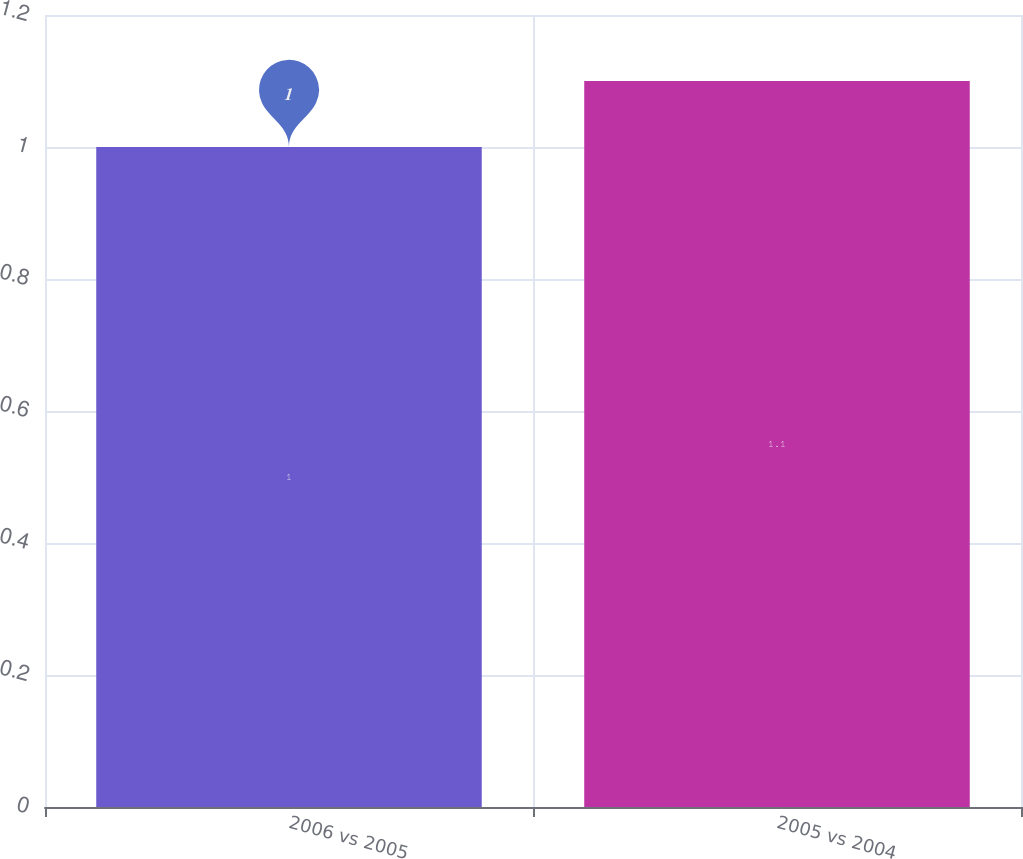Convert chart to OTSL. <chart><loc_0><loc_0><loc_500><loc_500><bar_chart><fcel>2006 vs 2005<fcel>2005 vs 2004<nl><fcel>1<fcel>1.1<nl></chart> 